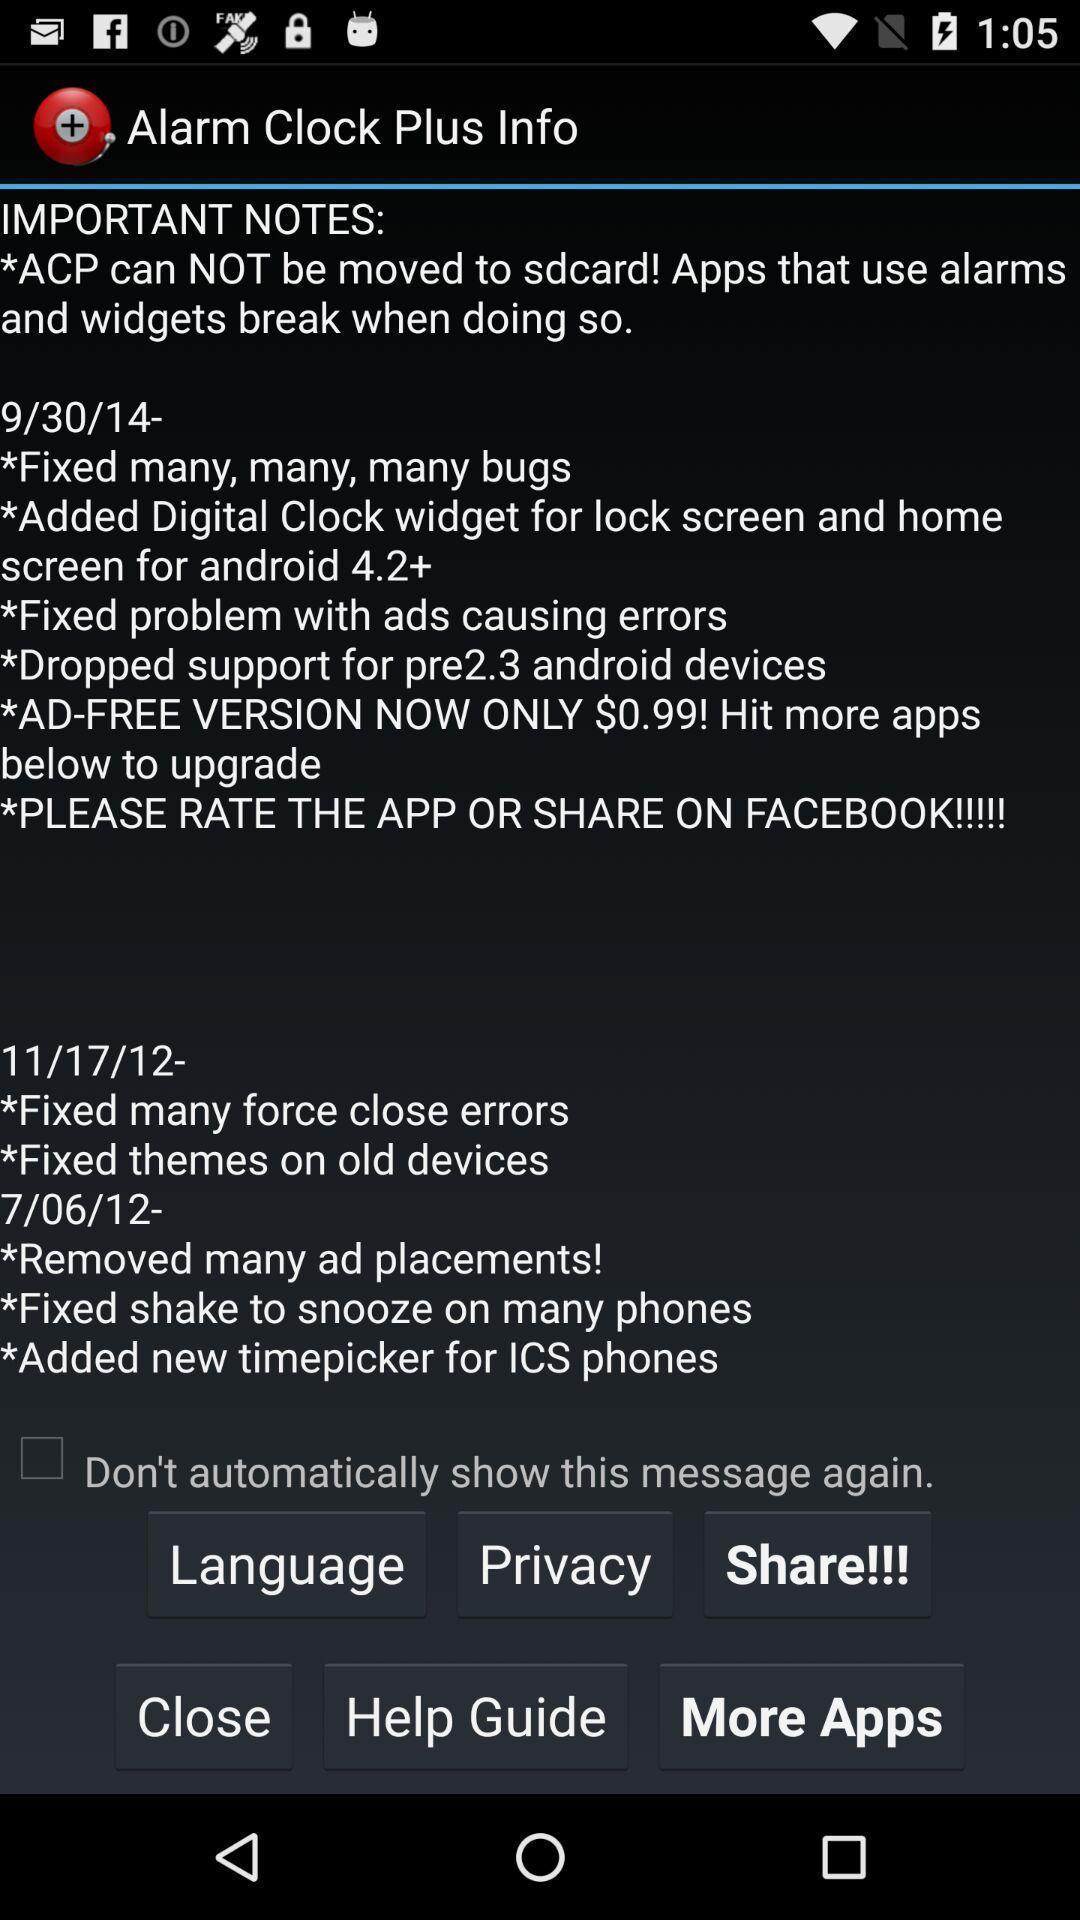Tell me what you see in this picture. Screen displaying the new alarm information. 